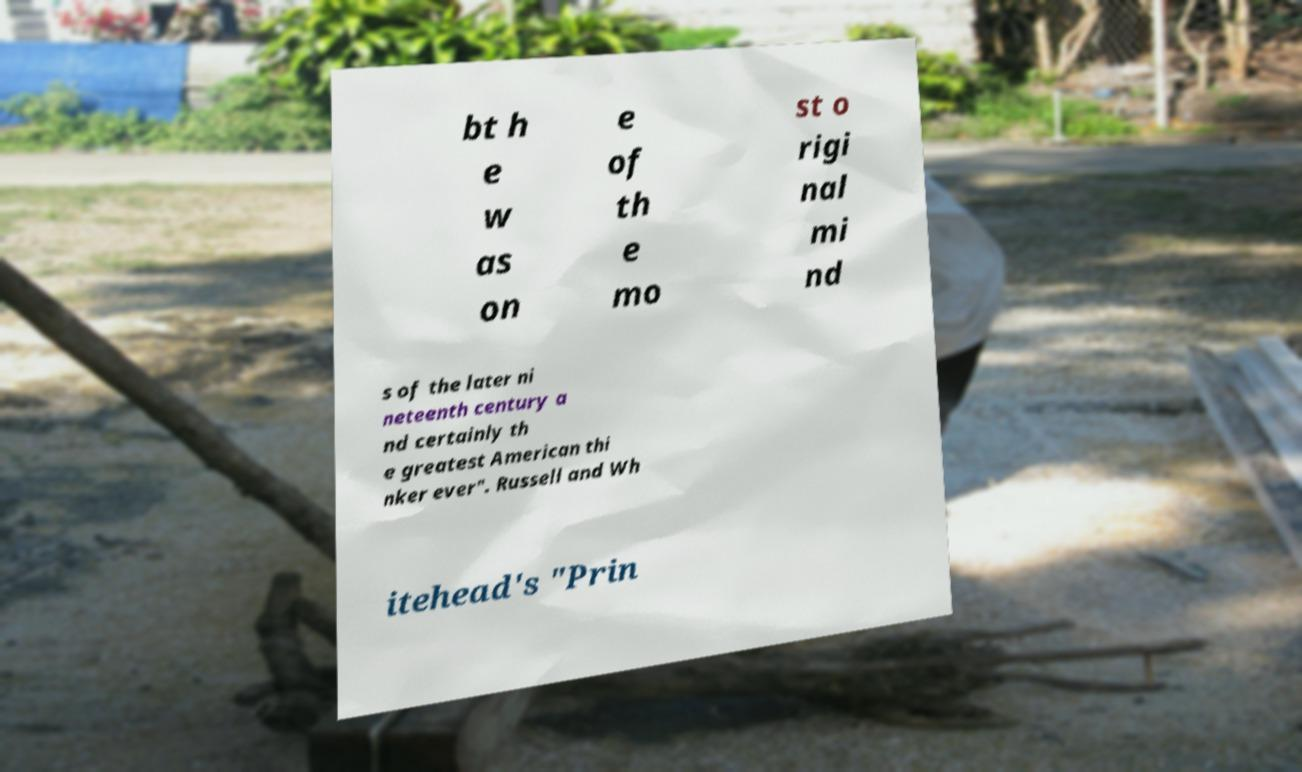There's text embedded in this image that I need extracted. Can you transcribe it verbatim? bt h e w as on e of th e mo st o rigi nal mi nd s of the later ni neteenth century a nd certainly th e greatest American thi nker ever". Russell and Wh itehead's "Prin 